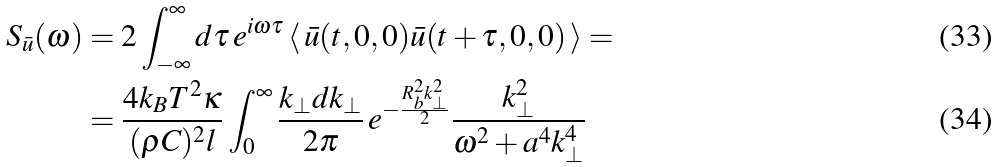<formula> <loc_0><loc_0><loc_500><loc_500>S _ { \bar { u } } ( \omega ) & = 2 \int _ { - \infty } ^ { \infty } d \tau \, e ^ { i \omega \tau } \, \langle \, \bar { u } ( t , 0 , 0 ) \bar { u } ( t + \tau , 0 , 0 ) \, \rangle = \\ & = \frac { 4 k _ { B } T ^ { 2 } \kappa } { ( \rho C ) ^ { 2 } l } \int _ { 0 } ^ { \infty } \frac { k _ { \bot } d k _ { \bot } } { 2 \pi } \, e ^ { - \frac { R _ { b } ^ { 2 } k _ { \bot } ^ { 2 } } { 2 } } \frac { k _ { \bot } ^ { 2 } } { \omega ^ { 2 } + a ^ { 4 } k _ { \bot } ^ { 4 } } \,</formula> 